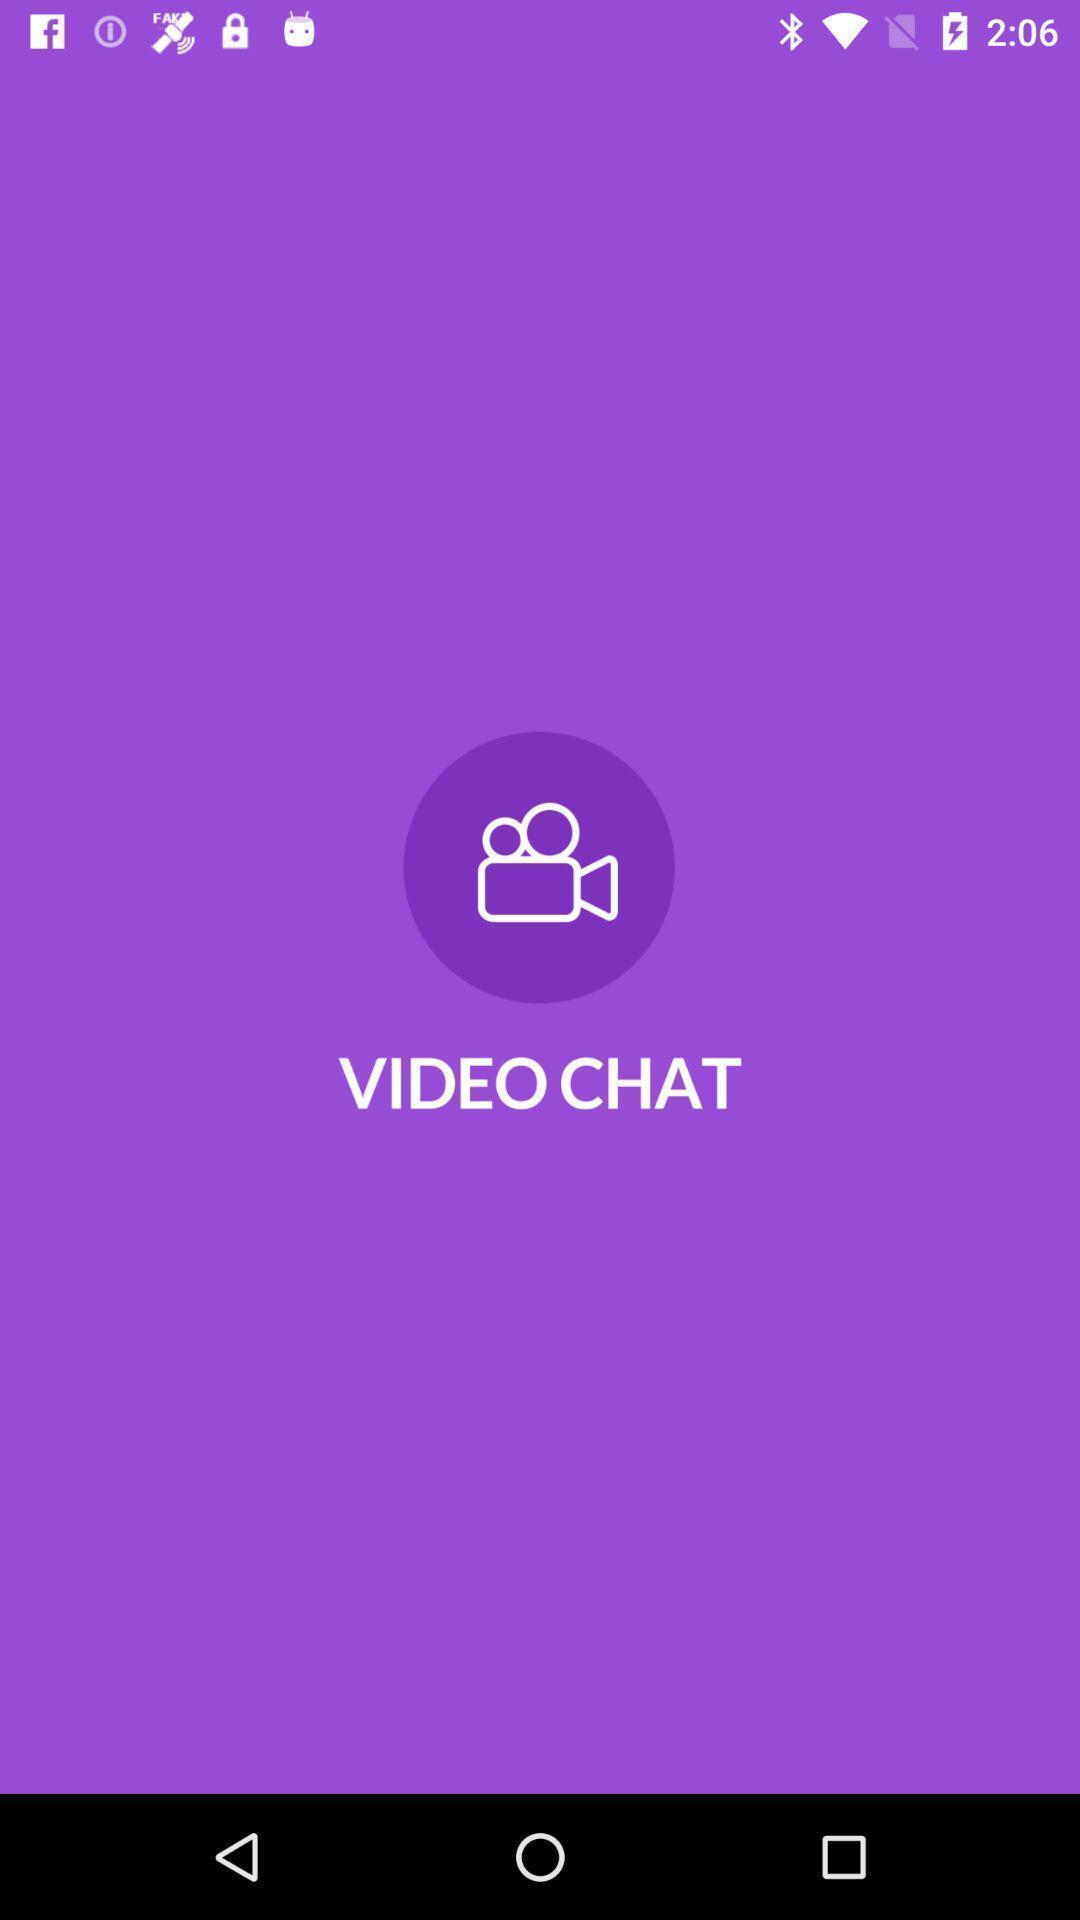Explain the elements present in this screenshot. Welcome page of a social application. 